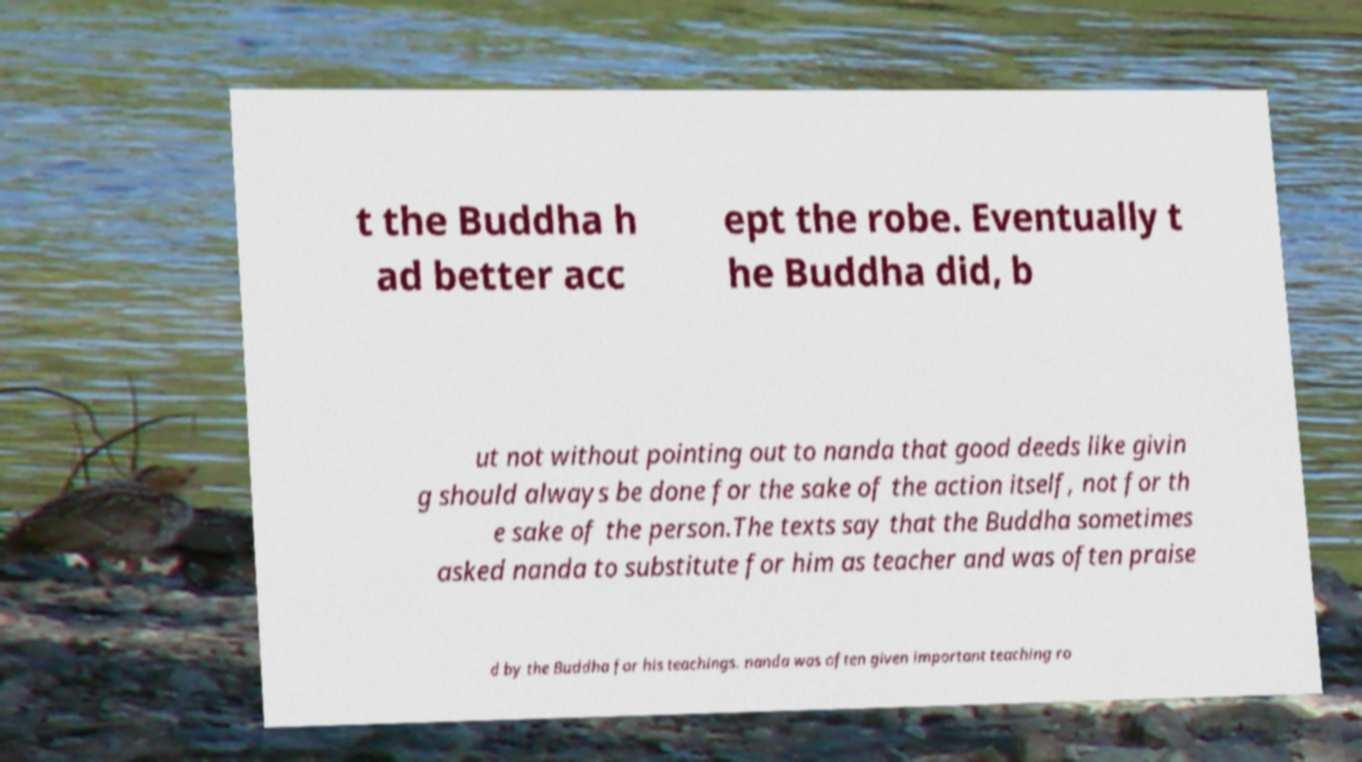Could you extract and type out the text from this image? t the Buddha h ad better acc ept the robe. Eventually t he Buddha did, b ut not without pointing out to nanda that good deeds like givin g should always be done for the sake of the action itself, not for th e sake of the person.The texts say that the Buddha sometimes asked nanda to substitute for him as teacher and was often praise d by the Buddha for his teachings. nanda was often given important teaching ro 